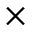<formula> <loc_0><loc_0><loc_500><loc_500>\times</formula> 